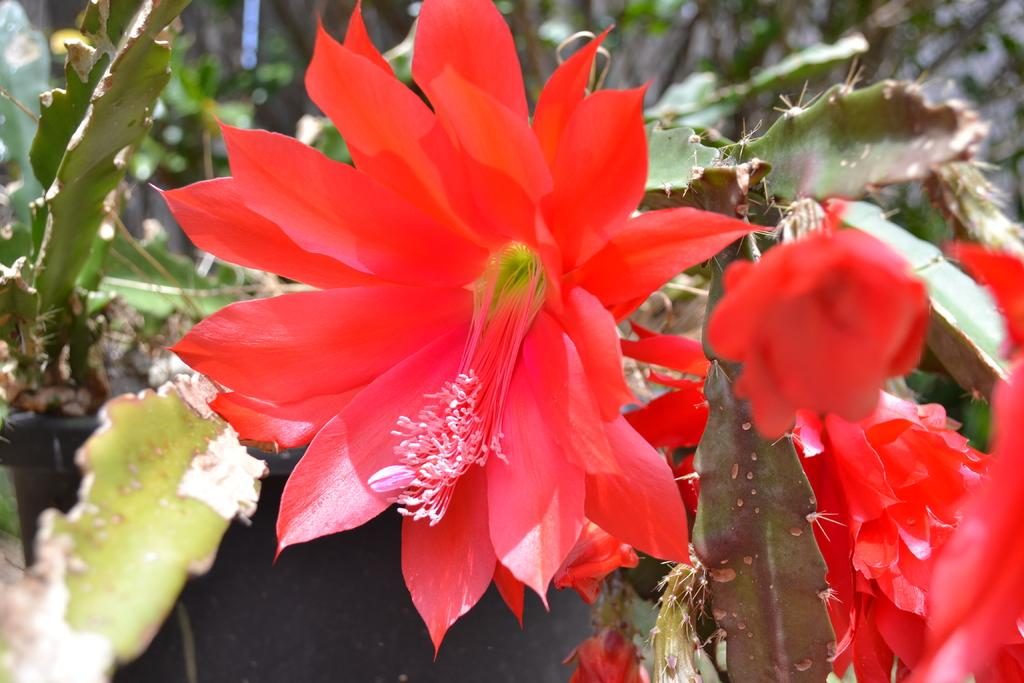What type of living organisms can be seen in the image? There are flowers on plants in the image. Can you describe the plants in the image? The plants in the image have flowers on them. What year is depicted in the image? The image does not depict a specific year; it features flowers on plants. What position does the ray hold in the image? There is no ray present in the image; it only features flowers on plants. 